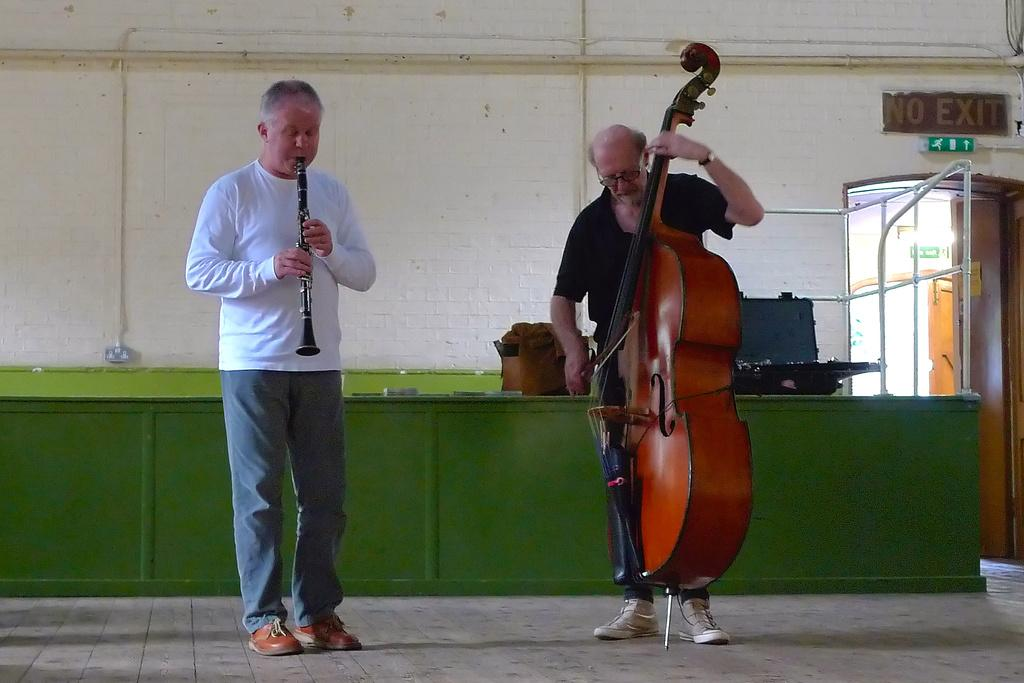Who or what can be seen in the image? There are people in the image. What are the people doing in the image? The people are standing in the image. What are the people holding in their hands? The people are holding musical instruments in their hands. What type of bells can be heard ringing in the image? There are no bells present in the image, and therefore no sound can be heard. 